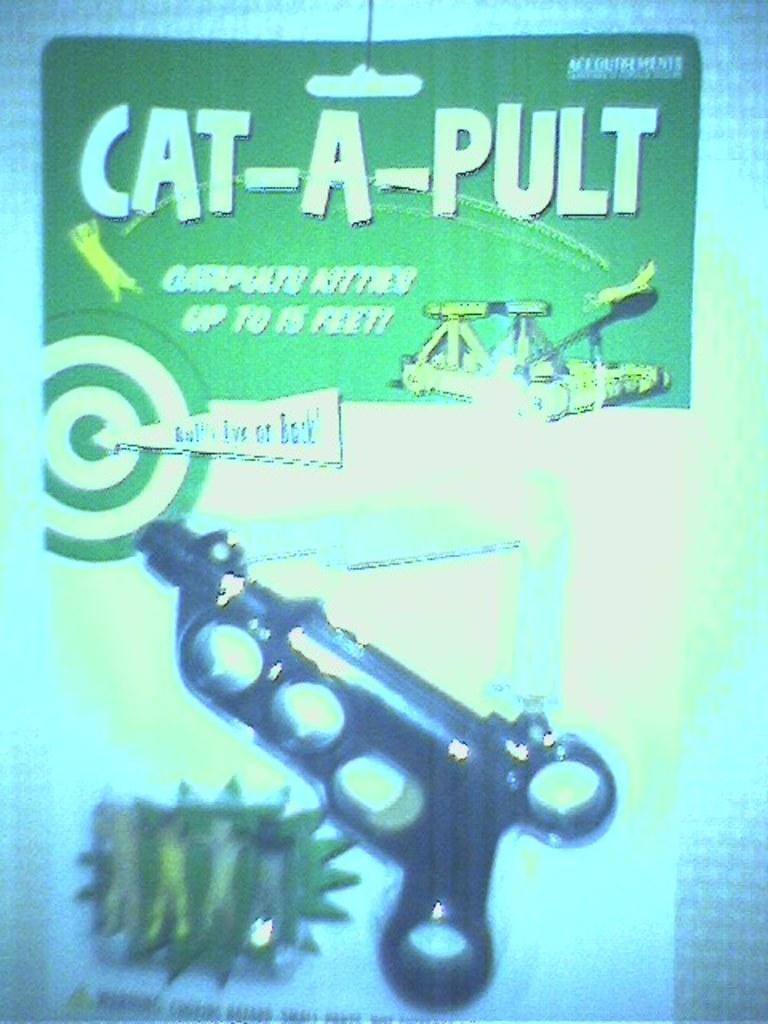<image>
Describe the image concisely. a new box of a pult toy is un opened package 